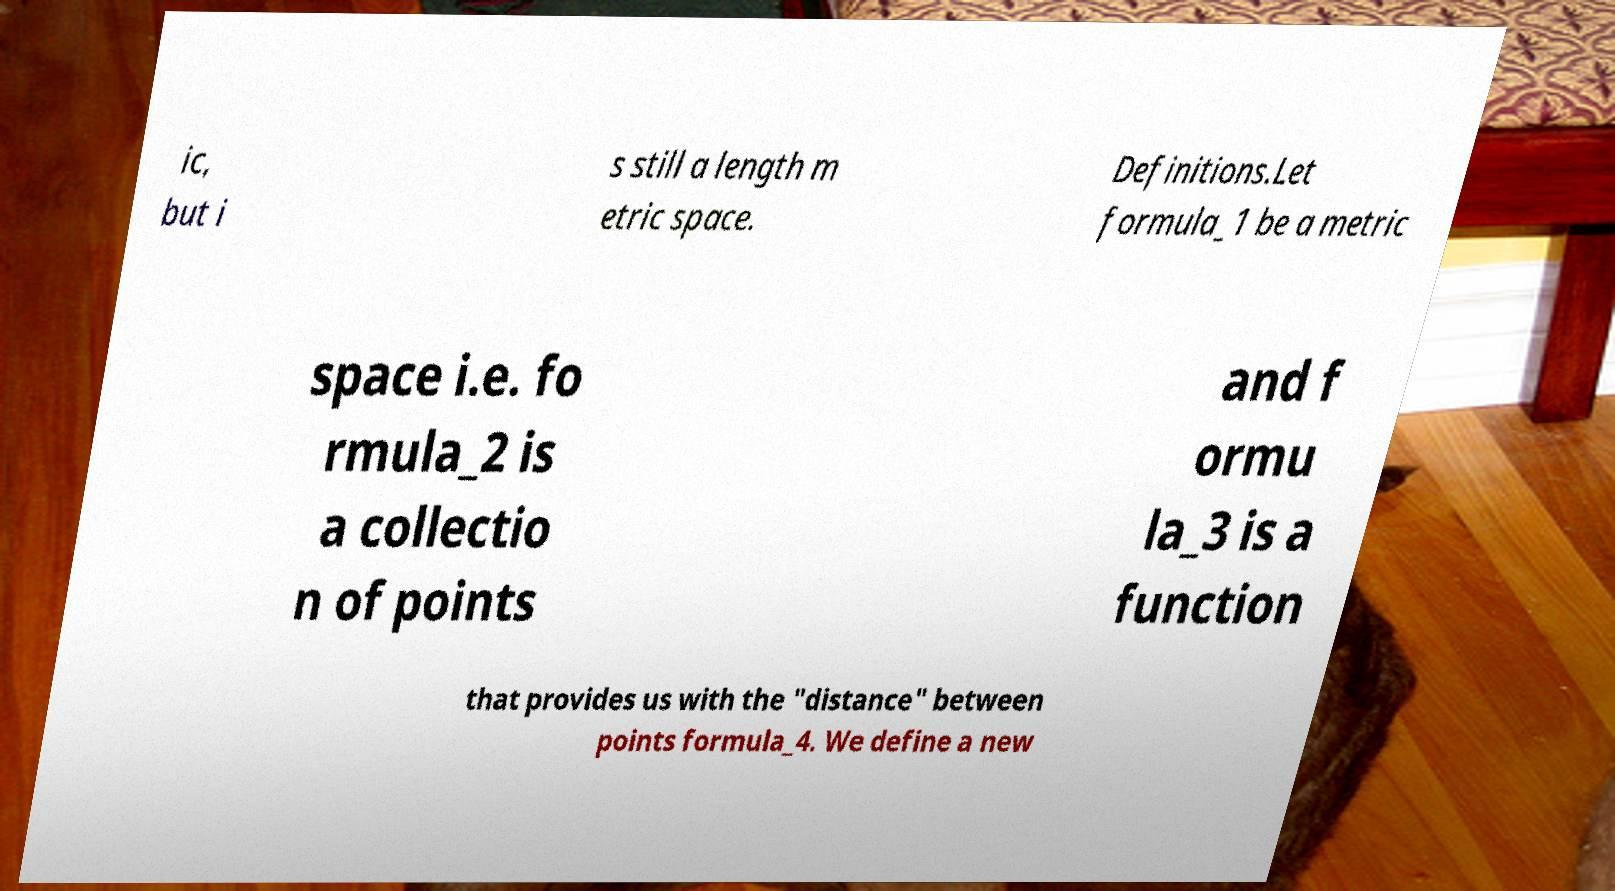What messages or text are displayed in this image? I need them in a readable, typed format. ic, but i s still a length m etric space. Definitions.Let formula_1 be a metric space i.e. fo rmula_2 is a collectio n of points and f ormu la_3 is a function that provides us with the "distance" between points formula_4. We define a new 